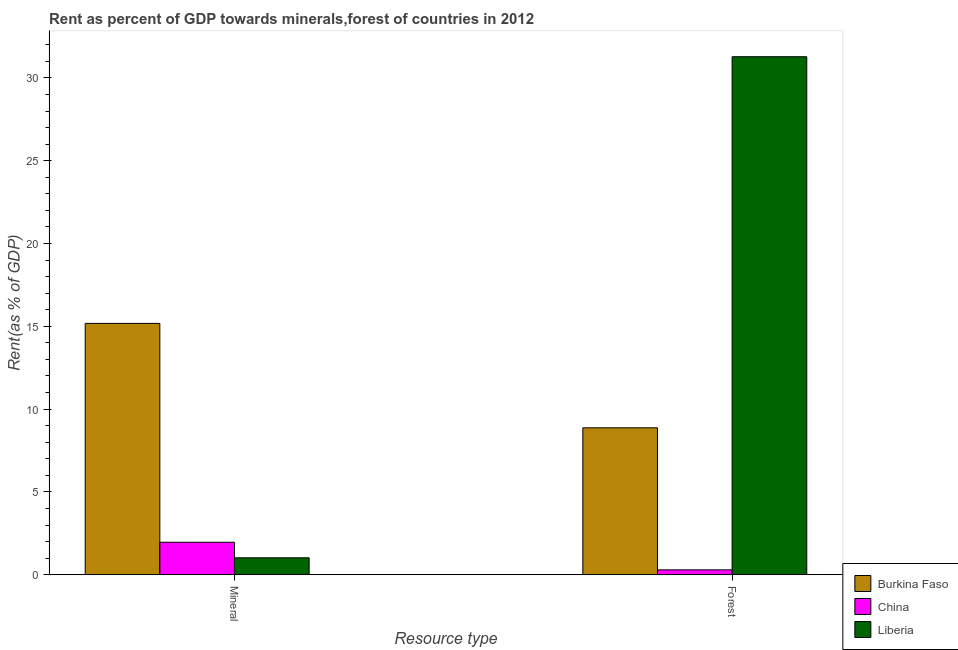How many different coloured bars are there?
Make the answer very short. 3. How many groups of bars are there?
Your response must be concise. 2. Are the number of bars on each tick of the X-axis equal?
Offer a terse response. Yes. How many bars are there on the 2nd tick from the left?
Your answer should be very brief. 3. How many bars are there on the 2nd tick from the right?
Offer a very short reply. 3. What is the label of the 1st group of bars from the left?
Provide a succinct answer. Mineral. What is the forest rent in Burkina Faso?
Provide a short and direct response. 8.87. Across all countries, what is the maximum forest rent?
Offer a terse response. 31.28. Across all countries, what is the minimum forest rent?
Your answer should be compact. 0.29. In which country was the forest rent maximum?
Keep it short and to the point. Liberia. In which country was the mineral rent minimum?
Ensure brevity in your answer.  Liberia. What is the total mineral rent in the graph?
Keep it short and to the point. 18.15. What is the difference between the forest rent in Liberia and that in China?
Make the answer very short. 30.99. What is the difference between the forest rent in Liberia and the mineral rent in China?
Your response must be concise. 29.32. What is the average forest rent per country?
Provide a short and direct response. 13.48. What is the difference between the mineral rent and forest rent in Burkina Faso?
Provide a short and direct response. 6.31. In how many countries, is the mineral rent greater than 1 %?
Offer a very short reply. 3. What is the ratio of the forest rent in China to that in Burkina Faso?
Give a very brief answer. 0.03. In how many countries, is the forest rent greater than the average forest rent taken over all countries?
Your response must be concise. 1. What does the 1st bar from the left in Forest represents?
Make the answer very short. Burkina Faso. What does the 3rd bar from the right in Mineral represents?
Make the answer very short. Burkina Faso. How many countries are there in the graph?
Offer a very short reply. 3. What is the difference between two consecutive major ticks on the Y-axis?
Your answer should be very brief. 5. Are the values on the major ticks of Y-axis written in scientific E-notation?
Your response must be concise. No. Where does the legend appear in the graph?
Offer a very short reply. Bottom right. How are the legend labels stacked?
Keep it short and to the point. Vertical. What is the title of the graph?
Your response must be concise. Rent as percent of GDP towards minerals,forest of countries in 2012. Does "Turks and Caicos Islands" appear as one of the legend labels in the graph?
Provide a succinct answer. No. What is the label or title of the X-axis?
Make the answer very short. Resource type. What is the label or title of the Y-axis?
Make the answer very short. Rent(as % of GDP). What is the Rent(as % of GDP) in Burkina Faso in Mineral?
Your response must be concise. 15.18. What is the Rent(as % of GDP) of China in Mineral?
Give a very brief answer. 1.96. What is the Rent(as % of GDP) of Liberia in Mineral?
Make the answer very short. 1.02. What is the Rent(as % of GDP) of Burkina Faso in Forest?
Keep it short and to the point. 8.87. What is the Rent(as % of GDP) of China in Forest?
Your answer should be very brief. 0.29. What is the Rent(as % of GDP) in Liberia in Forest?
Your answer should be compact. 31.28. Across all Resource type, what is the maximum Rent(as % of GDP) of Burkina Faso?
Ensure brevity in your answer.  15.18. Across all Resource type, what is the maximum Rent(as % of GDP) of China?
Provide a short and direct response. 1.96. Across all Resource type, what is the maximum Rent(as % of GDP) of Liberia?
Your response must be concise. 31.28. Across all Resource type, what is the minimum Rent(as % of GDP) of Burkina Faso?
Keep it short and to the point. 8.87. Across all Resource type, what is the minimum Rent(as % of GDP) in China?
Your answer should be compact. 0.29. Across all Resource type, what is the minimum Rent(as % of GDP) of Liberia?
Provide a succinct answer. 1.02. What is the total Rent(as % of GDP) in Burkina Faso in the graph?
Provide a short and direct response. 24.04. What is the total Rent(as % of GDP) of China in the graph?
Offer a terse response. 2.25. What is the total Rent(as % of GDP) of Liberia in the graph?
Give a very brief answer. 32.3. What is the difference between the Rent(as % of GDP) of Burkina Faso in Mineral and that in Forest?
Provide a short and direct response. 6.31. What is the difference between the Rent(as % of GDP) of China in Mineral and that in Forest?
Ensure brevity in your answer.  1.67. What is the difference between the Rent(as % of GDP) of Liberia in Mineral and that in Forest?
Keep it short and to the point. -30.26. What is the difference between the Rent(as % of GDP) in Burkina Faso in Mineral and the Rent(as % of GDP) in China in Forest?
Offer a very short reply. 14.88. What is the difference between the Rent(as % of GDP) in Burkina Faso in Mineral and the Rent(as % of GDP) in Liberia in Forest?
Your answer should be compact. -16.1. What is the difference between the Rent(as % of GDP) of China in Mineral and the Rent(as % of GDP) of Liberia in Forest?
Offer a terse response. -29.32. What is the average Rent(as % of GDP) of Burkina Faso per Resource type?
Ensure brevity in your answer.  12.02. What is the average Rent(as % of GDP) of China per Resource type?
Give a very brief answer. 1.12. What is the average Rent(as % of GDP) of Liberia per Resource type?
Provide a short and direct response. 16.15. What is the difference between the Rent(as % of GDP) in Burkina Faso and Rent(as % of GDP) in China in Mineral?
Offer a terse response. 13.22. What is the difference between the Rent(as % of GDP) in Burkina Faso and Rent(as % of GDP) in Liberia in Mineral?
Your response must be concise. 14.16. What is the difference between the Rent(as % of GDP) of China and Rent(as % of GDP) of Liberia in Mineral?
Give a very brief answer. 0.94. What is the difference between the Rent(as % of GDP) in Burkina Faso and Rent(as % of GDP) in China in Forest?
Your answer should be compact. 8.58. What is the difference between the Rent(as % of GDP) in Burkina Faso and Rent(as % of GDP) in Liberia in Forest?
Ensure brevity in your answer.  -22.41. What is the difference between the Rent(as % of GDP) of China and Rent(as % of GDP) of Liberia in Forest?
Provide a succinct answer. -30.99. What is the ratio of the Rent(as % of GDP) of Burkina Faso in Mineral to that in Forest?
Your answer should be very brief. 1.71. What is the ratio of the Rent(as % of GDP) in China in Mineral to that in Forest?
Your answer should be very brief. 6.73. What is the ratio of the Rent(as % of GDP) in Liberia in Mineral to that in Forest?
Ensure brevity in your answer.  0.03. What is the difference between the highest and the second highest Rent(as % of GDP) of Burkina Faso?
Provide a succinct answer. 6.31. What is the difference between the highest and the second highest Rent(as % of GDP) of China?
Your response must be concise. 1.67. What is the difference between the highest and the second highest Rent(as % of GDP) of Liberia?
Offer a terse response. 30.26. What is the difference between the highest and the lowest Rent(as % of GDP) of Burkina Faso?
Ensure brevity in your answer.  6.31. What is the difference between the highest and the lowest Rent(as % of GDP) in China?
Offer a very short reply. 1.67. What is the difference between the highest and the lowest Rent(as % of GDP) in Liberia?
Your answer should be very brief. 30.26. 